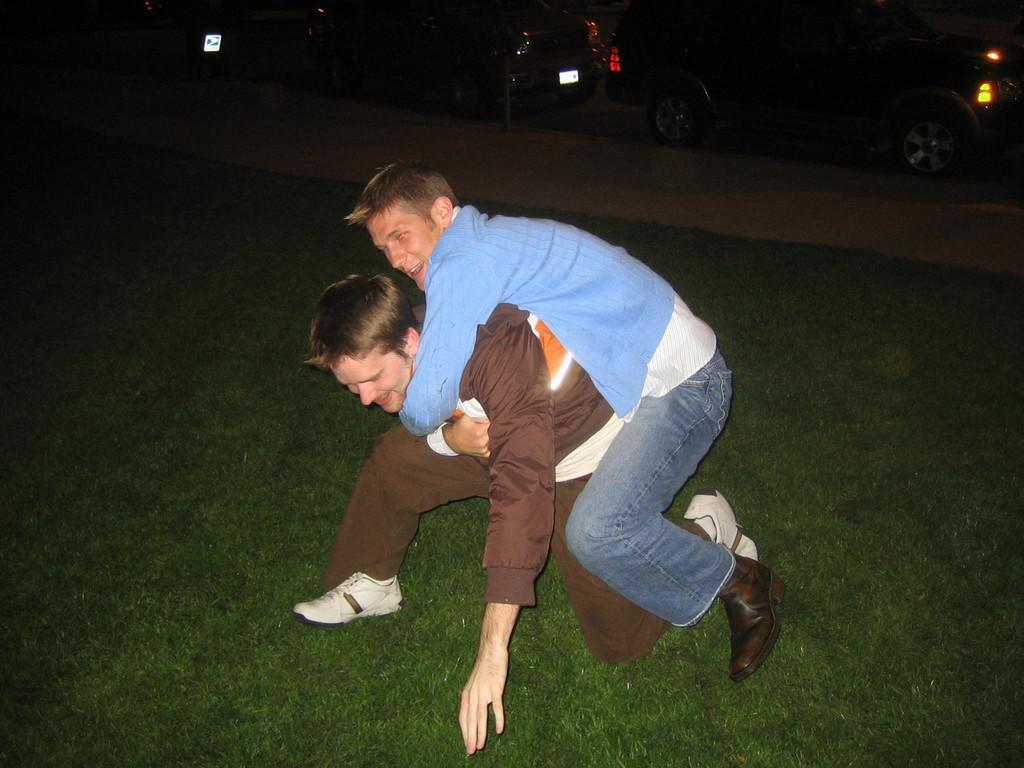Describe this image in one or two sentences. In this image there is a person on the grassland. He is carrying a person on his back. Top of the image there are vehicles on the path. 